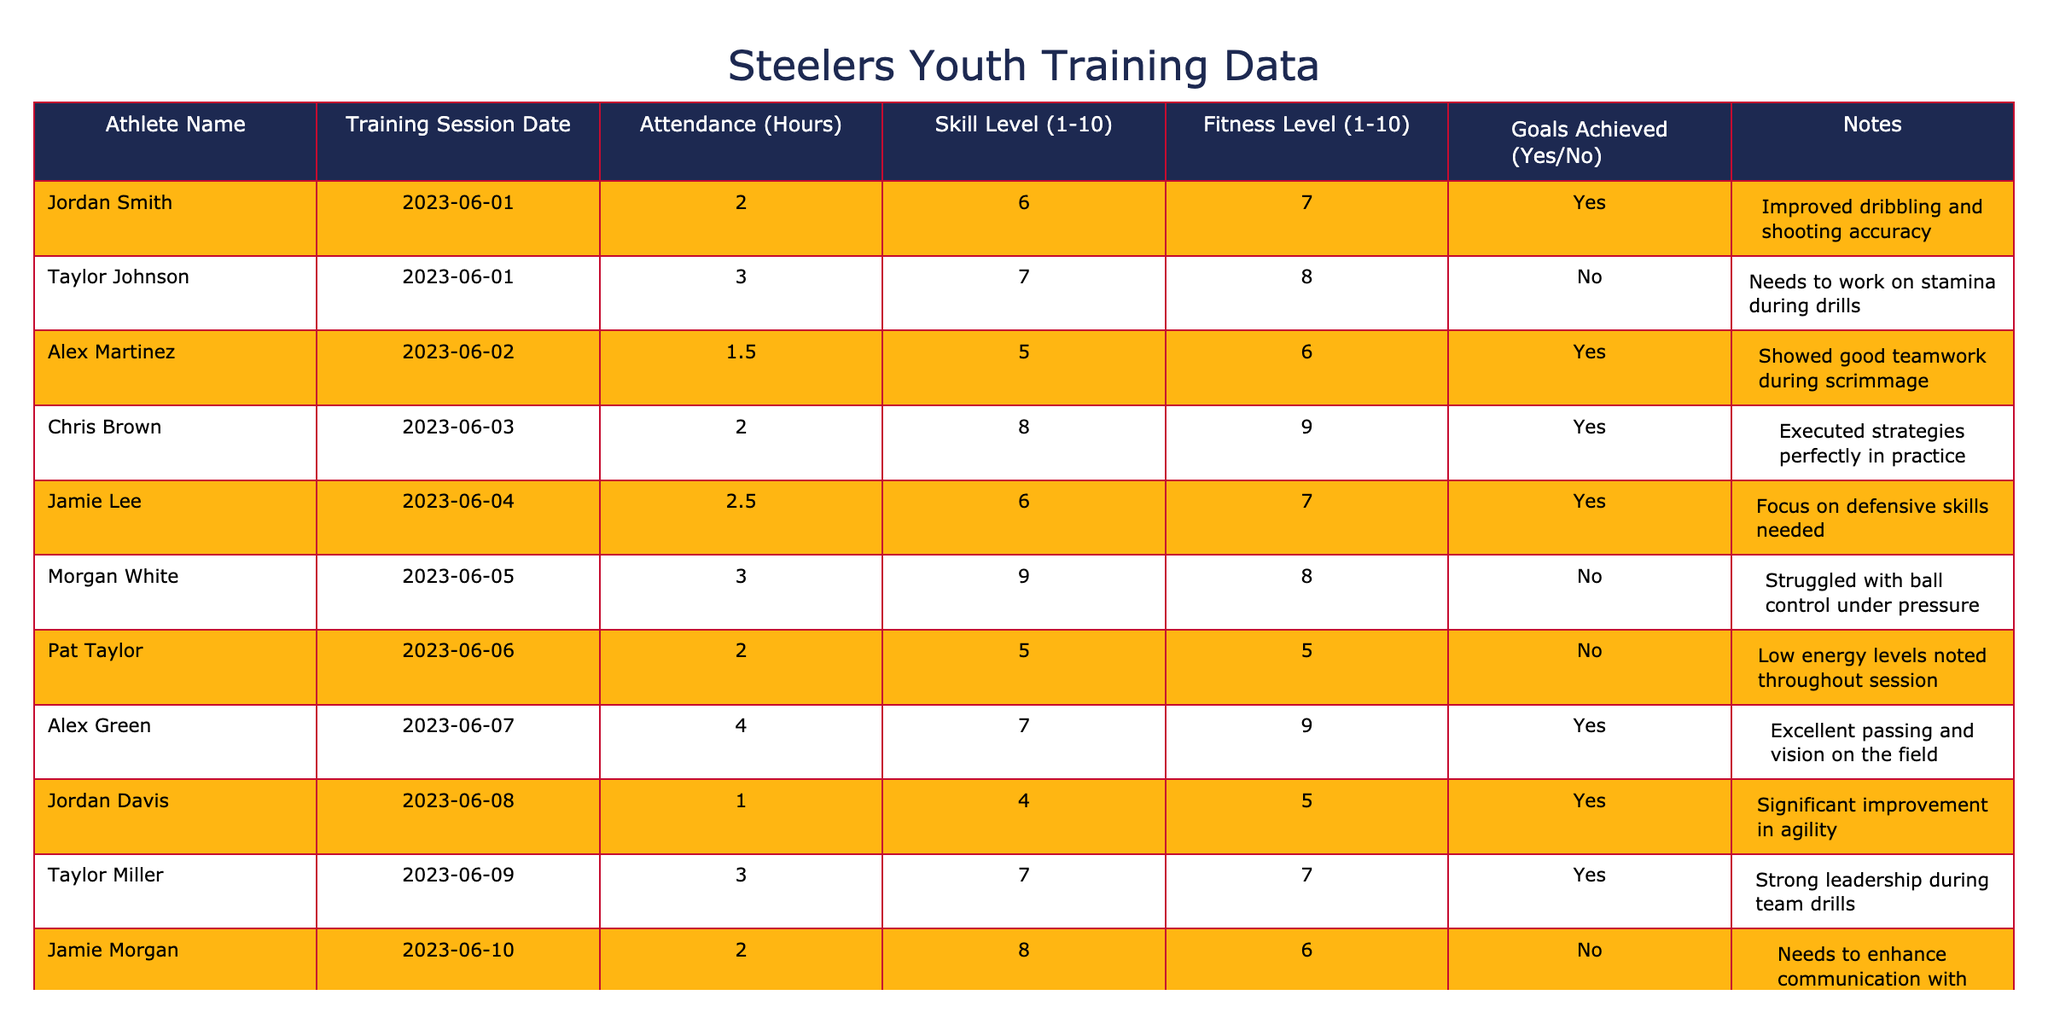What is the maximum attendance recorded in hours? The maximum attendance is found by comparing the values in the "Attendance (Hours)" column. The highest value is 4 hours, recorded for Alex Green on 2023-06-07.
Answer: 4 How many athletes achieved their goals during the training sessions? Counting the "Goals Achieved" column, there are 5 entries marked as 'Yes', indicating that those athletes achieved their goals.
Answer: 5 What is the average skill level of all athletes? To find the average skill level, sum all values in the "Skill Level (1-10)" column (6 + 7 + 5 + 8 + 6 + 9 + 5 + 7 + 4 + 7 + 8 + 9 = 81) and divide by the number of athletes (12). Therefore, the average skill level is 81 / 12 = 6.75.
Answer: 6.75 Which athlete had the highest fitness level, and what was their score? By checking the "Fitness Level (1-10)" column, the highest score is 9, achieved by Chris Brown and Alex Green. It indicates those athletes excelled in fitness.
Answer: Chris Brown and Alex Green, score 9 Was there any athlete who attended all sessions and achieved their goals? Reviewing the attendance and goal achievement, no athlete attended all sessions; thus, this situation does not exist among the data provided.
Answer: No How many sessions did Morgan White attend, and what was their goal status? Morgan White attended one session on 2023-06-05, and in the "Goals Achieved" column for that session, it states 'No', meaning they did not achieve their goals.
Answer: 1 session, No What is the total attendance in hours for all athletes? Sum the values from the "Attendance (Hours)" column (2 + 3 + 1.5 + 2 + 2.5 + 3 + 2 + 4 + 1 + 3 + 2 + 2.5 = 25). Thus, the total attendance sums to 25 hours.
Answer: 25 Which athlete had the lowest skill level, and what is that level? Checking the "Skill Level (1-10)" column, Alex Martinez has the lowest score of 5.
Answer: Alex Martinez, 5 How many athletes have a fitness level greater than or equal to 8? By counting the entries in the "Fitness Level (1-10)" column, 5 athletes (Chris Brown, Morgan White, Alex Green, Taylor Miller, Chris Hill) have scores of 8 or above, indicating good fitness levels.
Answer: 5 Is there a correlation between attendance hours and goals achieved? By examining the data, athletes who attended more hours, such as Alex Green, had mixed results in achieving goals. There is no clear correlation; hence, one cannot definitively claim an overall relationship based solely on the table.
Answer: No clear correlation What skill level must an athlete reach to achieve their goals based on the session data? Observing the entries where goals were achieved, the skill level varies mostly between 6 and 9, suggesting that a skill level of at least 6 is generally required to likely achieve goals.
Answer: At least 6 skill level 